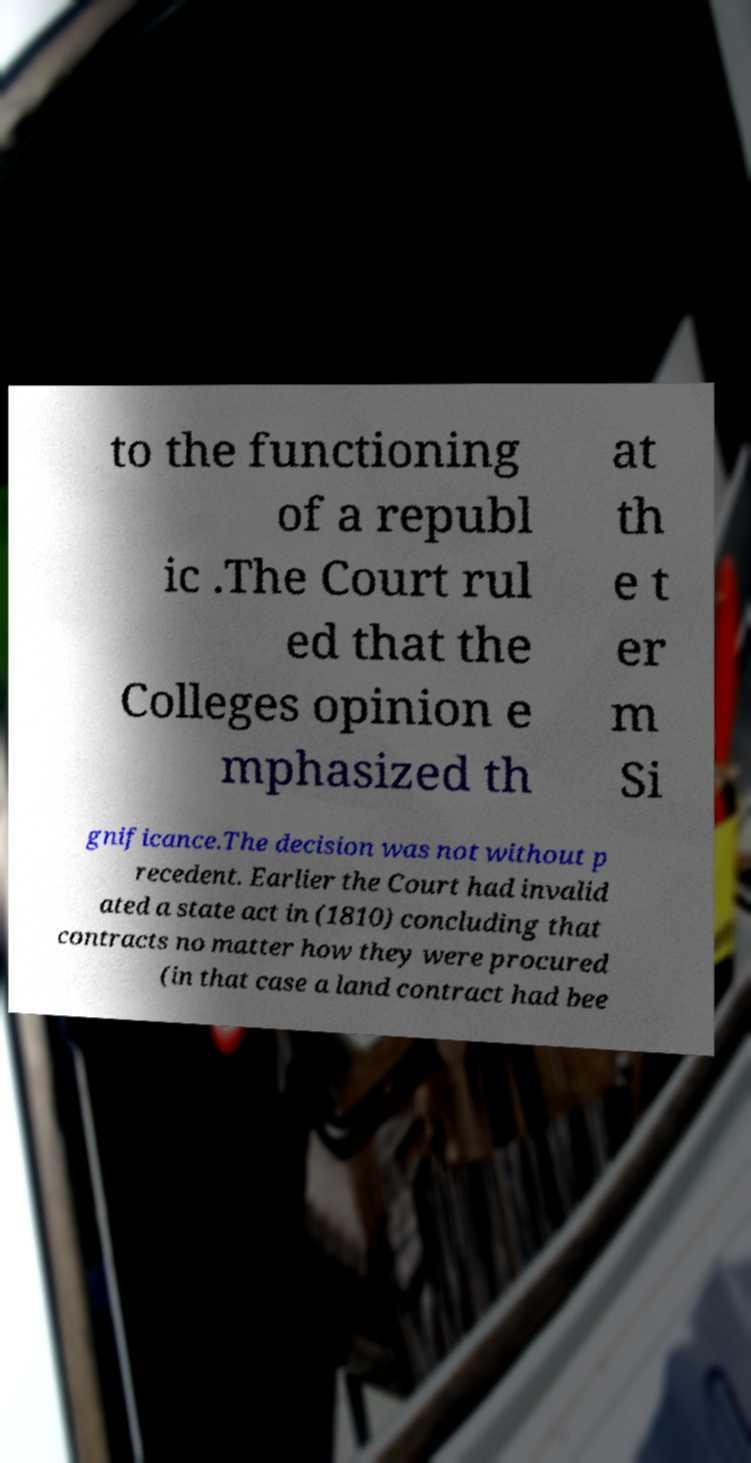For documentation purposes, I need the text within this image transcribed. Could you provide that? to the functioning of a republ ic .The Court rul ed that the Colleges opinion e mphasized th at th e t er m Si gnificance.The decision was not without p recedent. Earlier the Court had invalid ated a state act in (1810) concluding that contracts no matter how they were procured (in that case a land contract had bee 